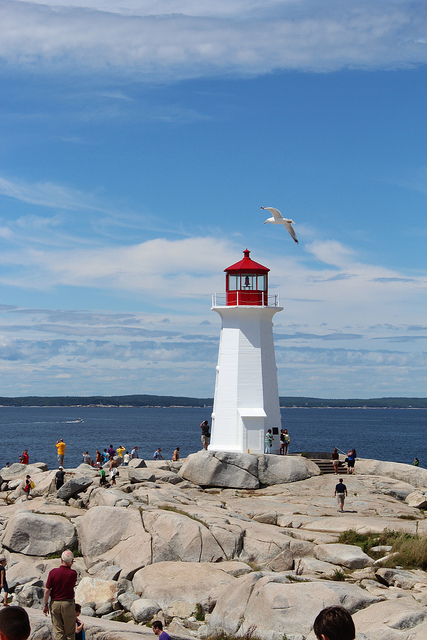How many remote controls are in the photo? 0 